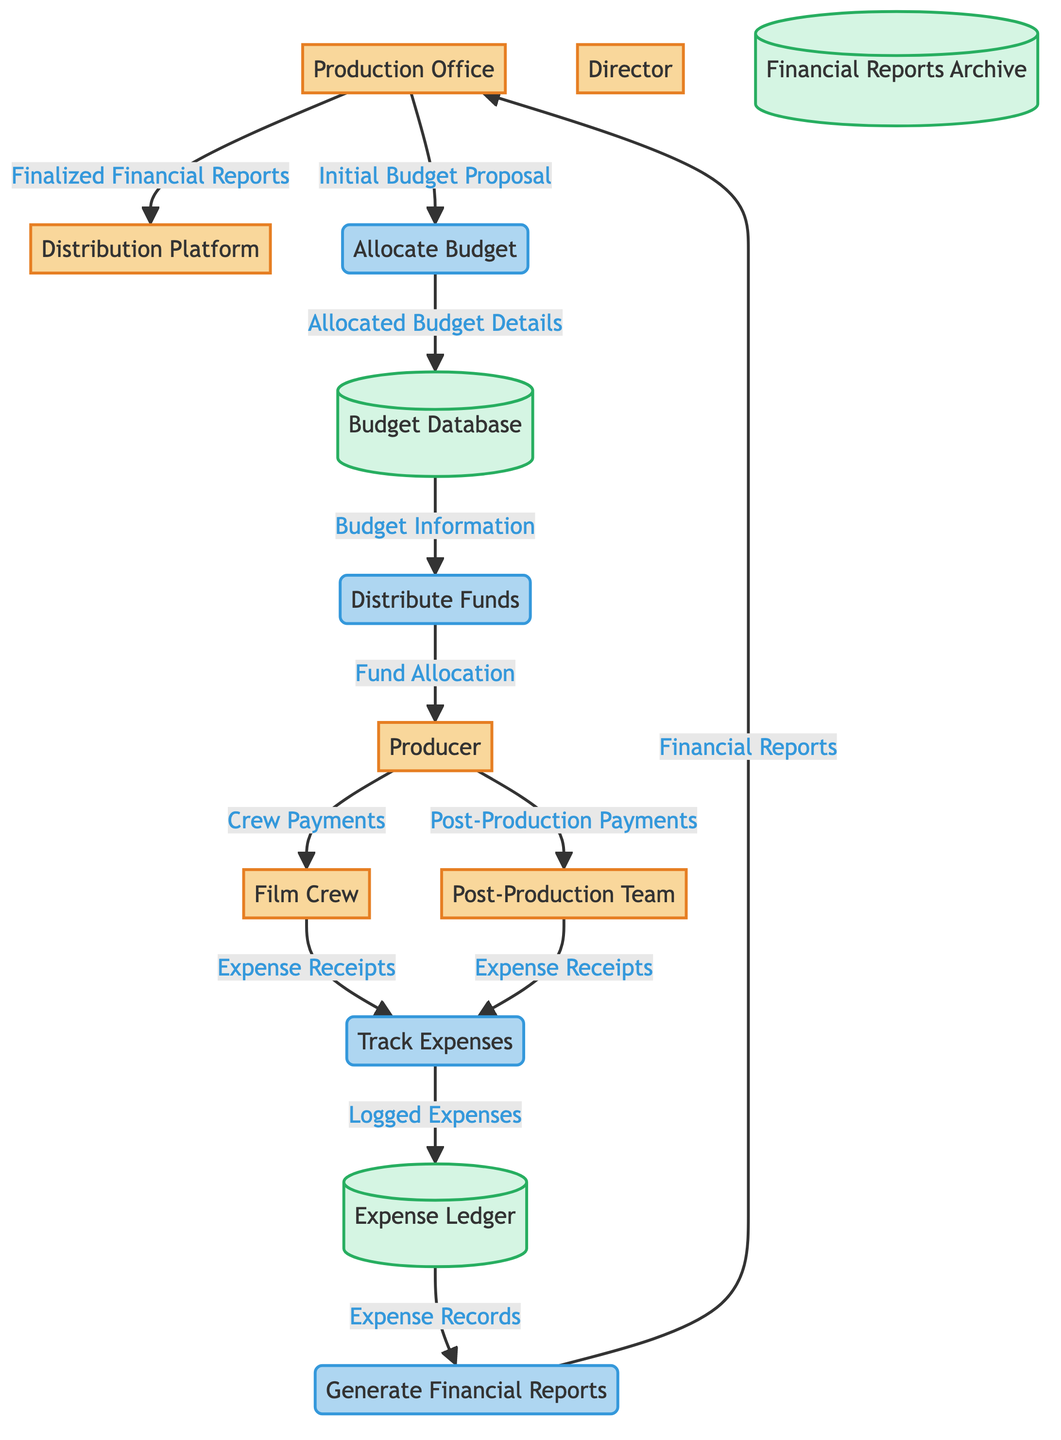What is the initial input to the Allocate Budget process? The diagram shows that the initial input to the Allocate Budget process comes from the Production Office as the "Initial Budget Proposal."
Answer: Initial Budget Proposal How many external entities are represented in the diagram? By counting the external entities listed in the diagram, there are six: Production Office, Director, Producer, Film Crew, Post-Production Team, and Distribution Platform.
Answer: 6 What type of data does the Distribute Funds process output to the Producer? The Distribute Funds process outputs "Fund Allocation" to the Producer, which is indicated by the arrow connecting these two nodes.
Answer: Fund Allocation Which data store receives data from the Track Expenses process? The Track Expenses process sends "Logged Expenses" to the Expense Ledger data store, as shown by their connecting arrow.
Answer: Expense Ledger What is the final output of the Generate Financial Reports process? The final output of the Generate Financial Reports process is "Financial Reports," which it sends to the Production Office based on the diagram's flow.
Answer: Financial Reports Which two entities receive payments from the Producer? The diagram indicates that the Producer makes payments to two entities: the Film Crew and the Post-Production Team, as shown by the arrows leading from the Producer to these entities.
Answer: Film Crew, Post-Production Team From which data store does Generate Financial Reports take its input data? Generate Financial Reports receives its input data, labeled as "Expense Records," from the Expense Ledger data store according to the diagram flow.
Answer: Expense Ledger What is the relationship between the Expense Ledger and the Generate Financial Reports process? The relationship is that the Expense Ledger provides "Expense Records" to the Generate Financial Reports process, establishing a data flow between these two components.
Answer: Expense Records What happens to the "Allocated Budget Details" after they are created? Once "Allocated Budget Details" are created by the Allocate Budget process, they are sent to the Budget Database, as shown in the diagram.
Answer: Budget Database 